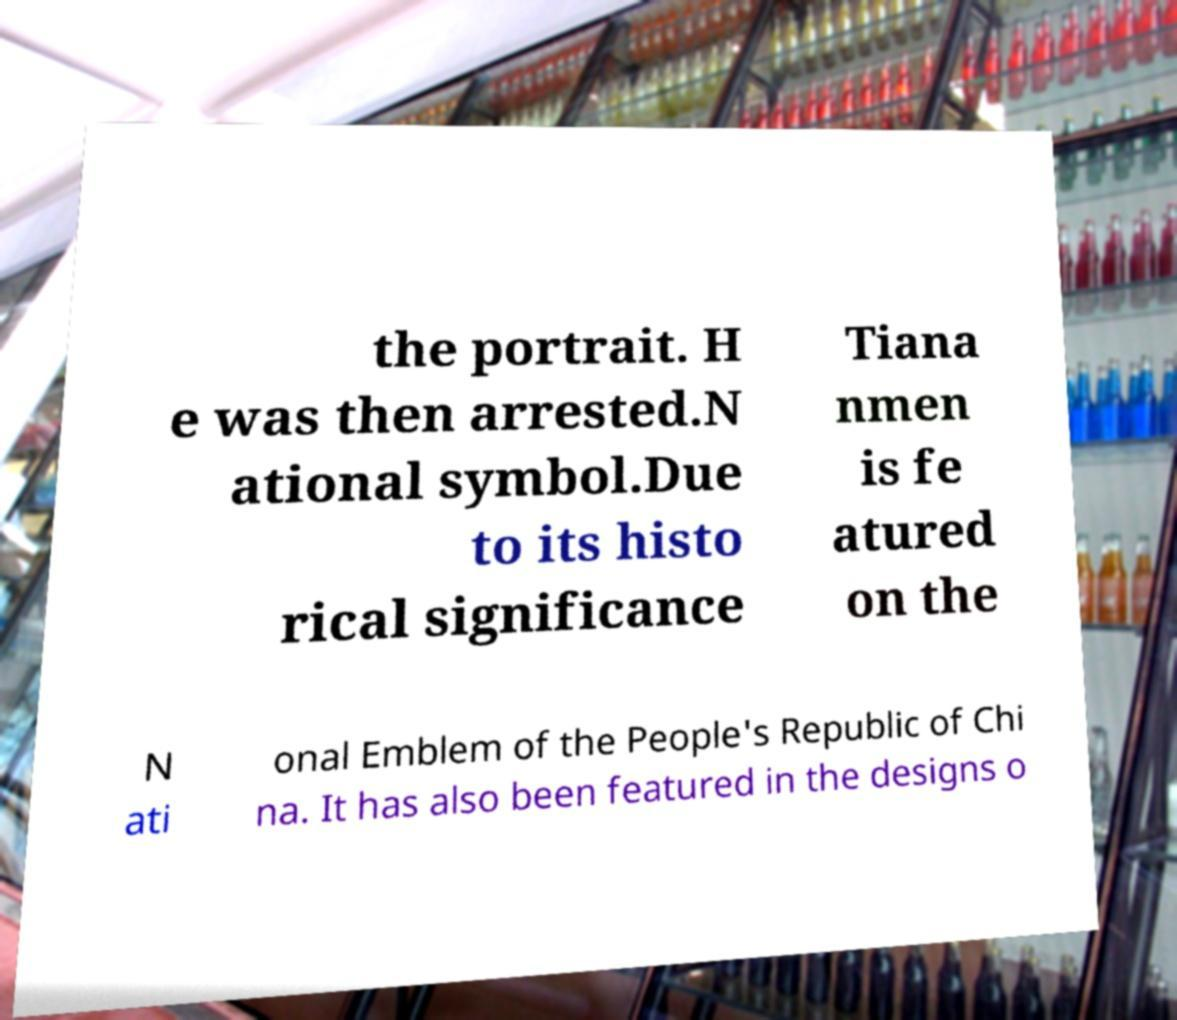Can you read and provide the text displayed in the image?This photo seems to have some interesting text. Can you extract and type it out for me? the portrait. H e was then arrested.N ational symbol.Due to its histo rical significance Tiana nmen is fe atured on the N ati onal Emblem of the People's Republic of Chi na. It has also been featured in the designs o 